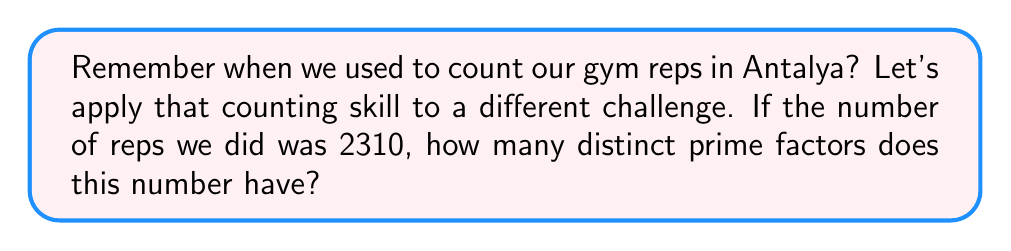Provide a solution to this math problem. Let's approach this step-by-step:

1) First, we need to find the prime factorization of 2310.

2) We can start dividing 2310 by the smallest prime number possible at each step:

   $2310 = 2 \times 1155$
   $1155 = 3 \times 385$
   $385 = 5 \times 77$
   $77 = 7 \times 11$

3) Therefore, the prime factorization of 2310 is:

   $2310 = 2 \times 3 \times 5 \times 7 \times 11$

4) Now, we simply need to count the number of distinct prime factors.

5) In this case, we have 5 distinct prime factors: 2, 3, 5, 7, and 11.

6) Each of these prime factors appears only once in the factorization, but even if they appeared multiple times, we would still only count them once as we're looking for distinct prime factors.
Answer: 5 